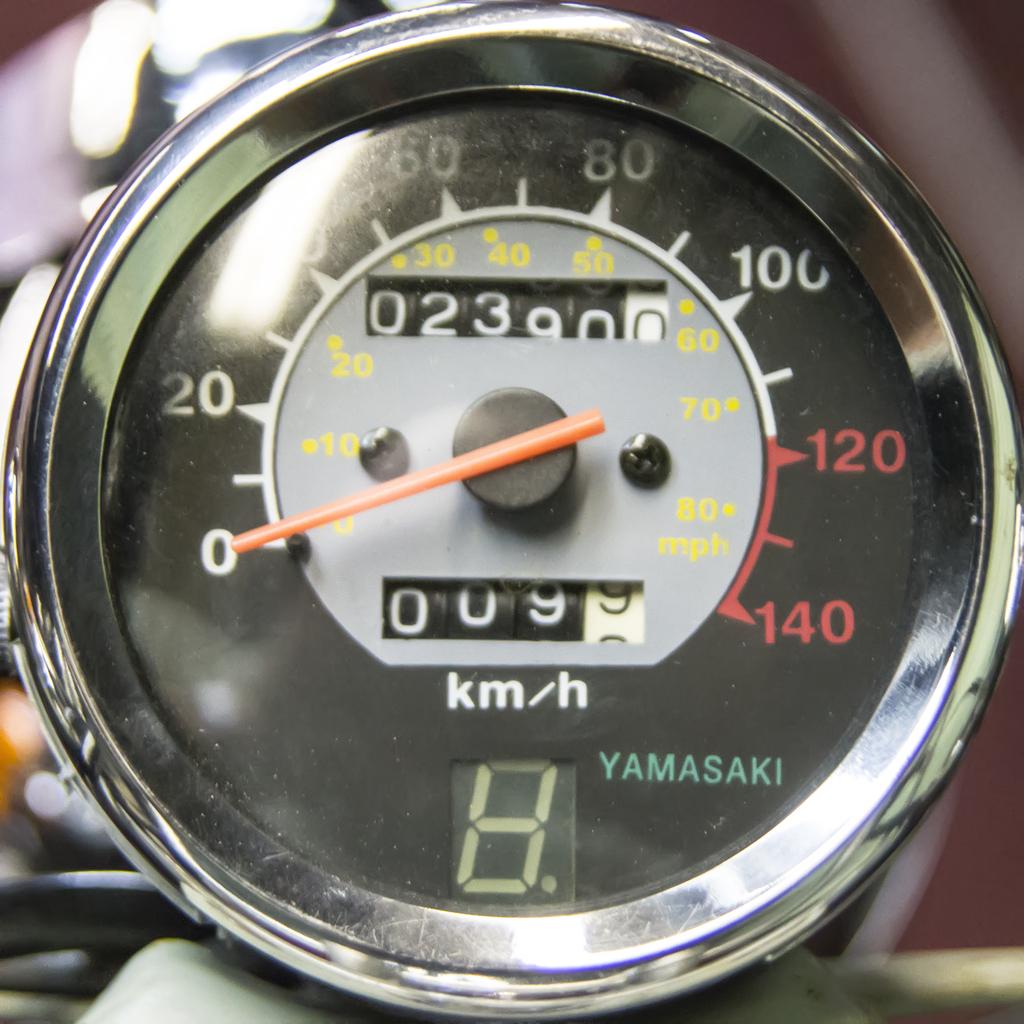What brand is the speedometer for?
Ensure brevity in your answer.  Yamasaki. What is the top speed of the dial?
Keep it short and to the point. 140. 